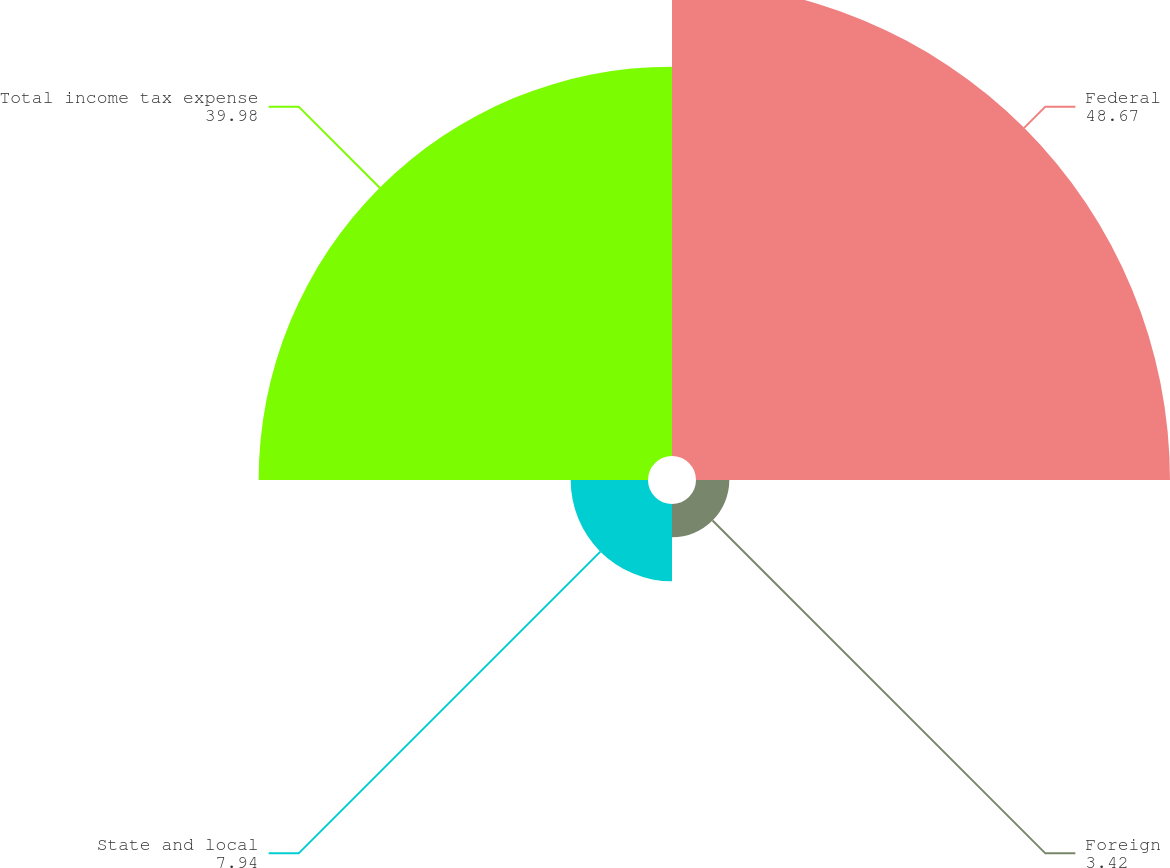Convert chart. <chart><loc_0><loc_0><loc_500><loc_500><pie_chart><fcel>Federal<fcel>Foreign<fcel>State and local<fcel>Total income tax expense<nl><fcel>48.67%<fcel>3.42%<fcel>7.94%<fcel>39.98%<nl></chart> 